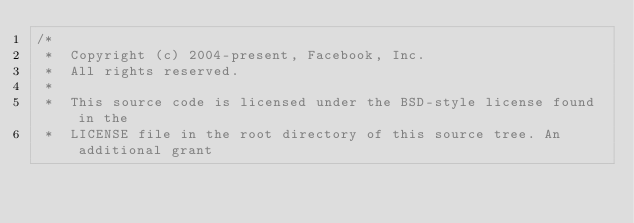<code> <loc_0><loc_0><loc_500><loc_500><_C++_>/*
 *  Copyright (c) 2004-present, Facebook, Inc.
 *  All rights reserved.
 *
 *  This source code is licensed under the BSD-style license found in the
 *  LICENSE file in the root directory of this source tree. An additional grant</code> 